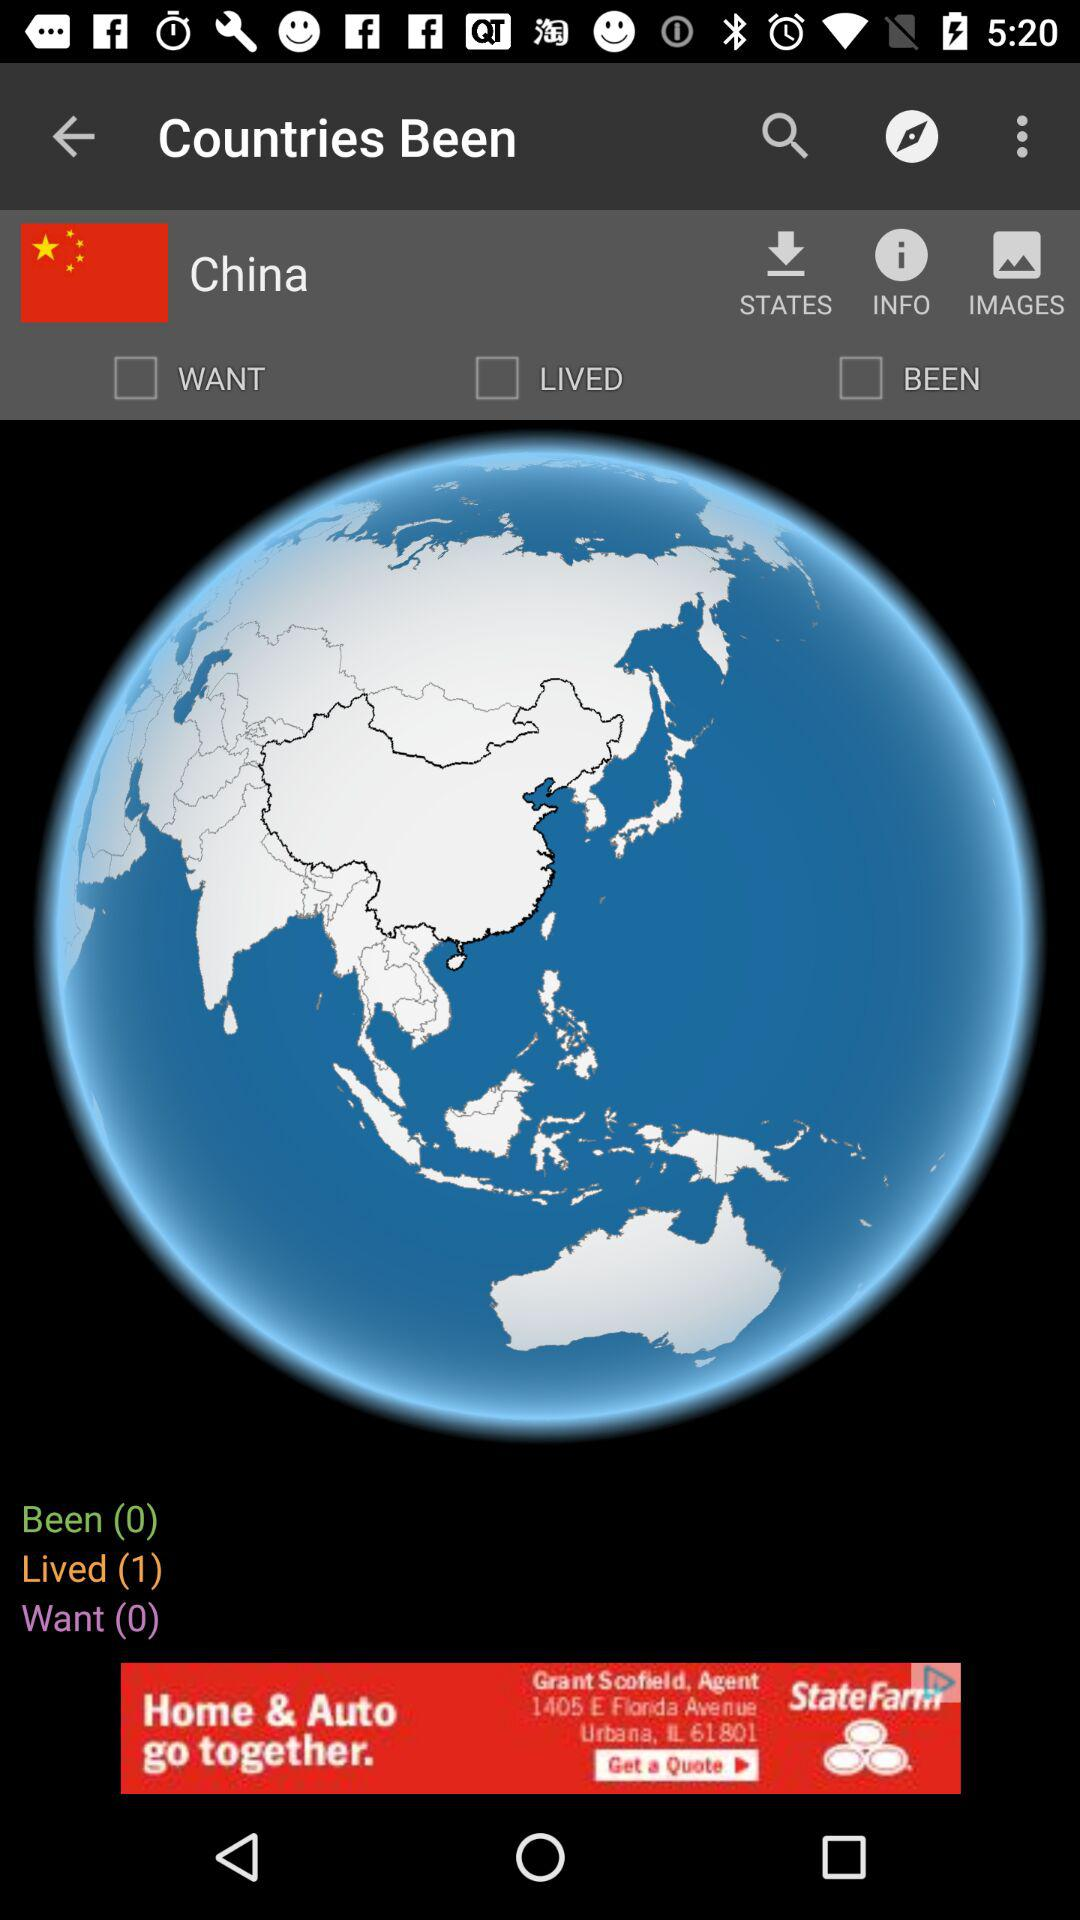How many "Lived" are there? There is 1 lived. 